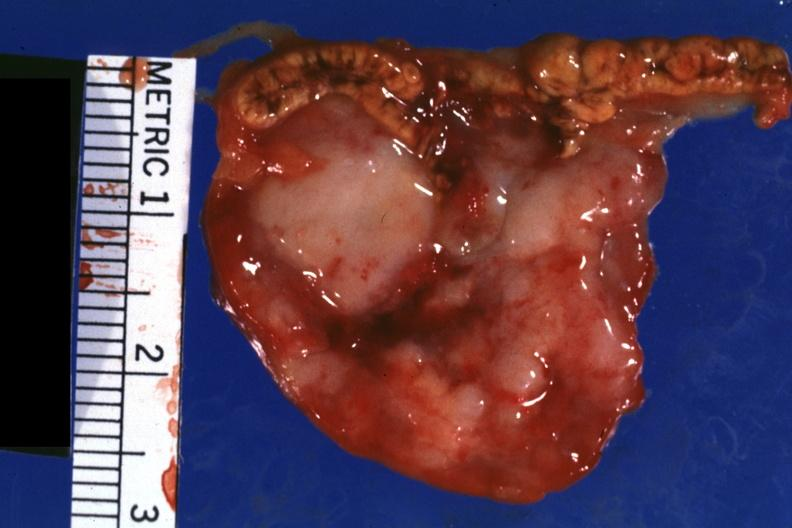s close-up tumor shown well?
Answer the question using a single word or phrase. Yes 